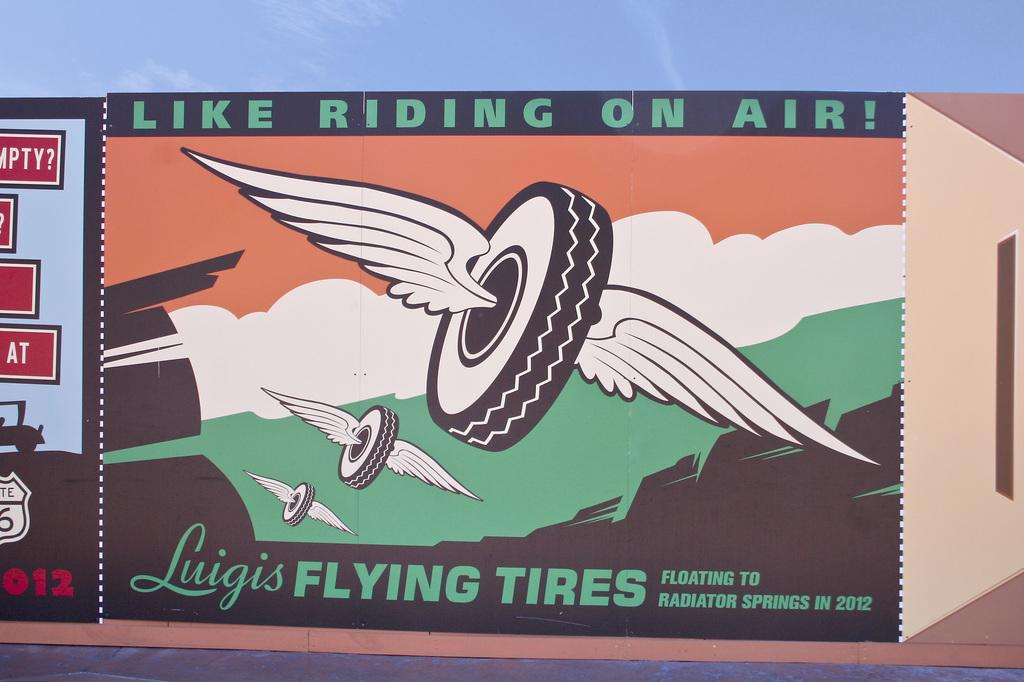What type of artwork is the image? The image is a painting. What object is depicted in the painting? There is a tyre depicted in the painting. What additional feature is shown in the painting? There are wings depicted in the painting. What other element is present in the painting? There is text depicted in the painting. Can you tell me how the bear is enjoying its pleasure in the painting? There is no bear present in the painting; it features a tyre, wings, and text. What type of writing instrument is the writer using in the painting? There is no writer or writing instrument depicted in the painting; it only features a tyre, wings, and text. 